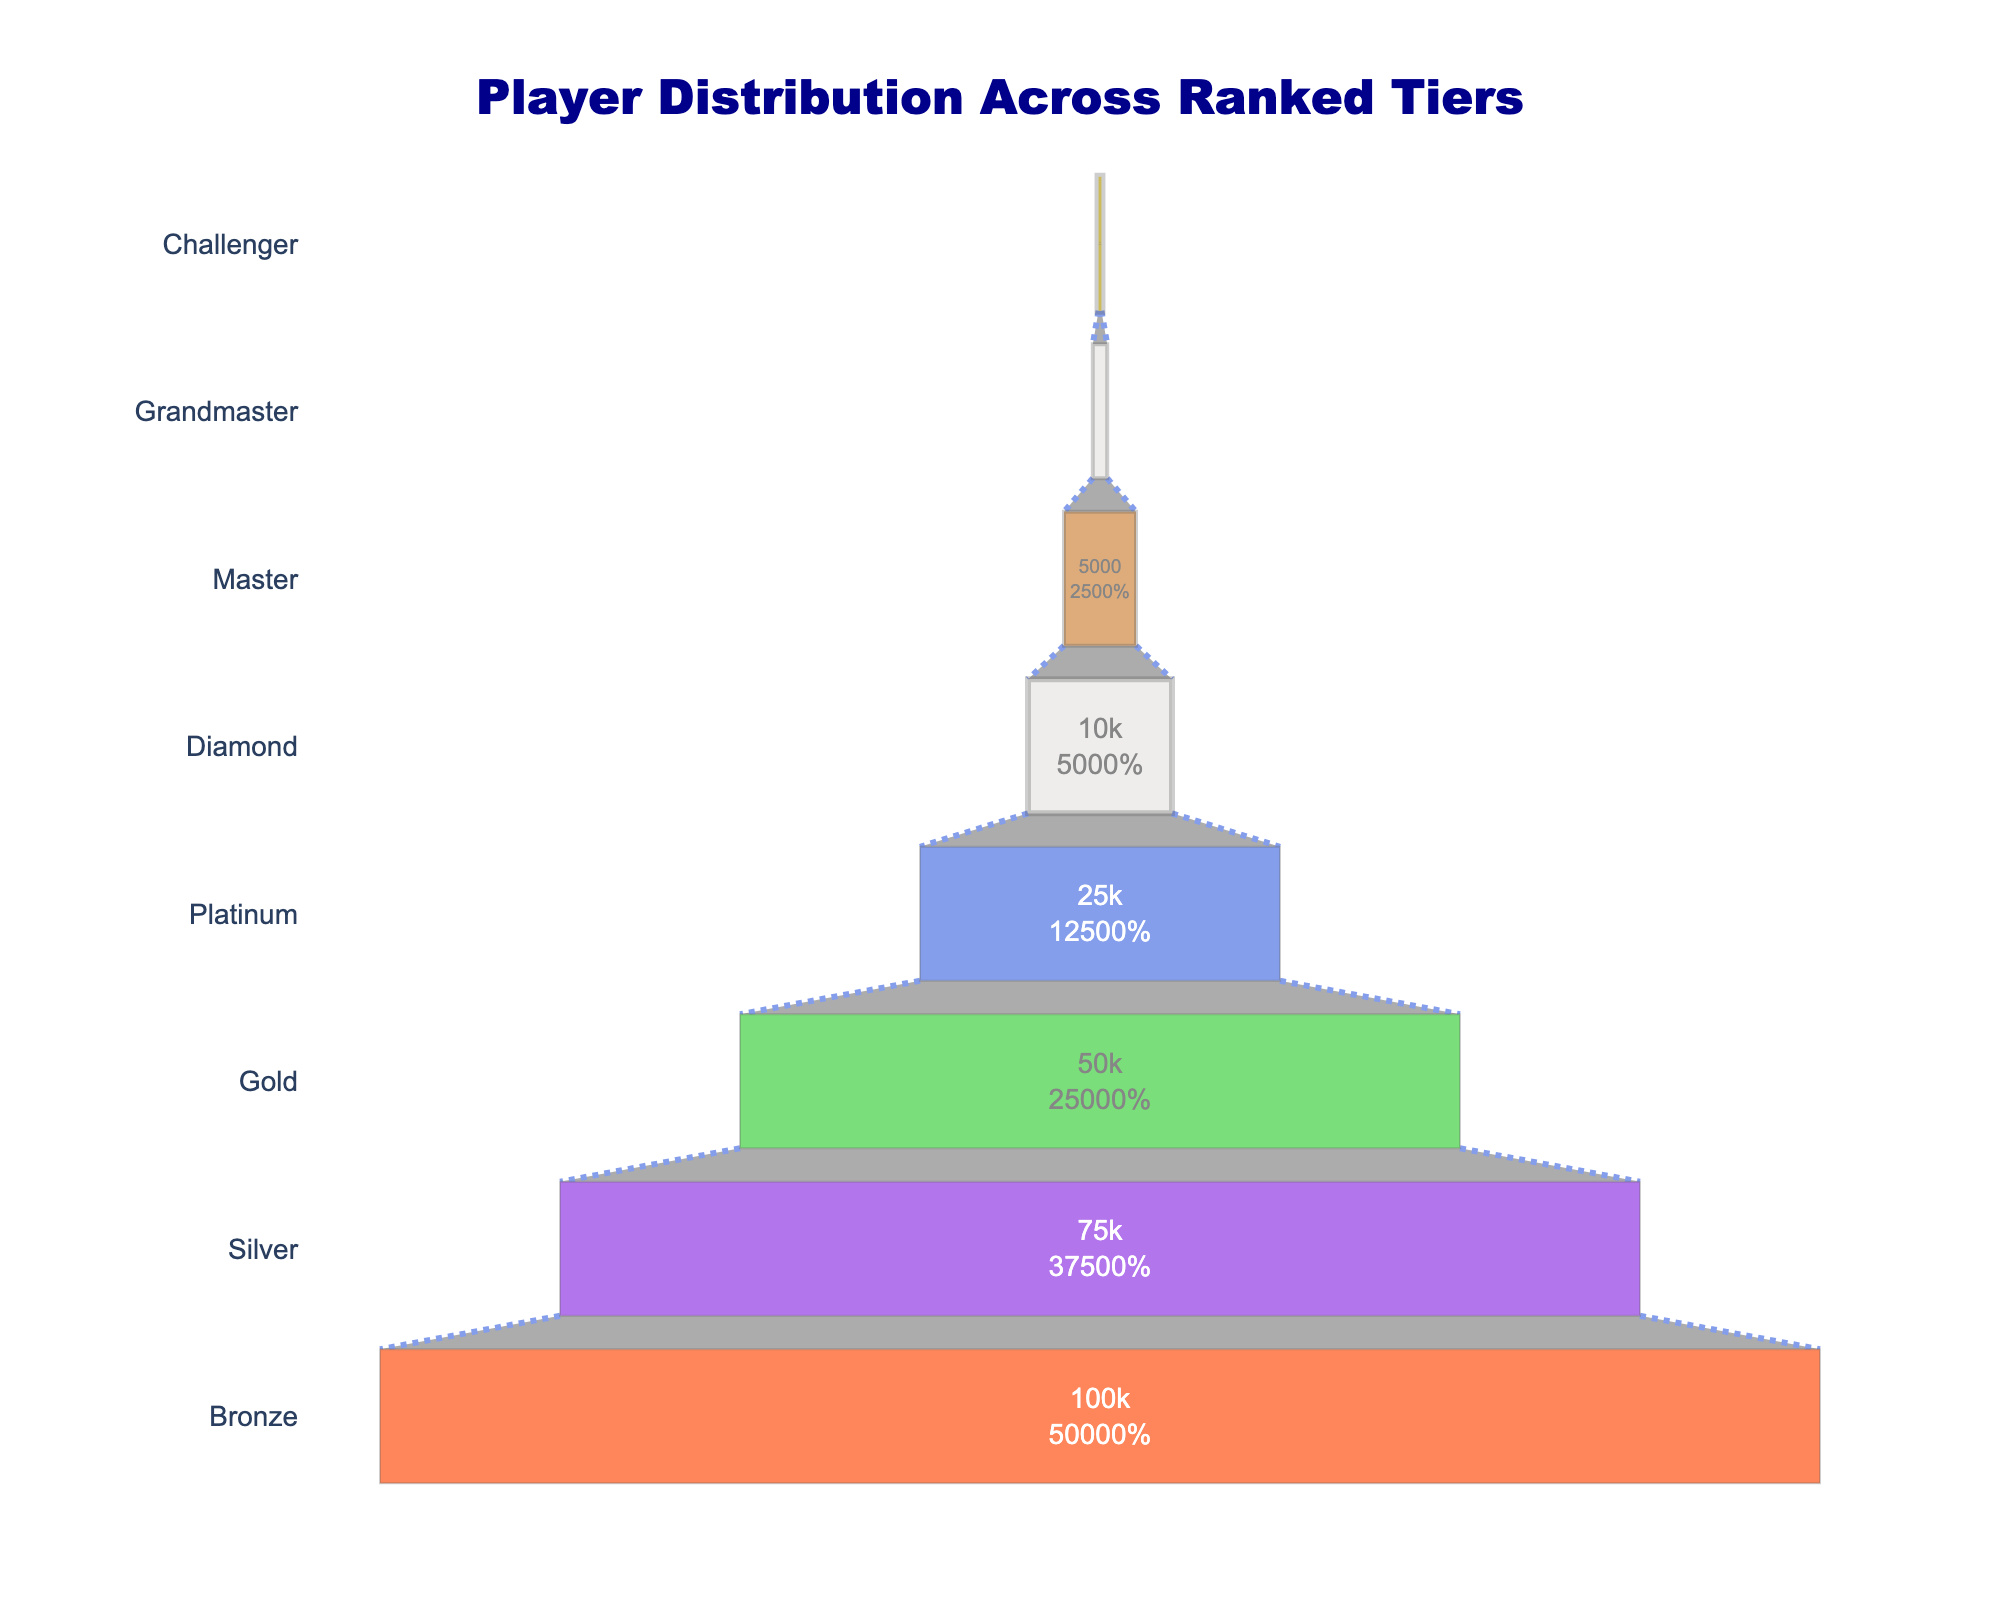How many players are there in the Challenger tier? The funnel chart specifies the number of players at each tier, listing Challenger with 200 players.
Answer: 200 What is the total number of players from Gold to Diamond? Sum the players in Gold (50,000), Platinum (25,000), and Diamond (10,000). 50,000 + 25,000 + 10,000 = 85,000
Answer: 85,000 Which tier has the highest number of players? The chart shows that the Bronze tier has the most players with 100,000.
Answer: Bronze How many players are there in tiers above Diamond? Sum the players in Master (5,000), Grandmaster (1,000), and Challenger (200). 5,000 + 1,000 + 200 = 6,200
Answer: 6,200 What percentage of players are in the Master tier compared to the total player base? Calculate the percentage by dividing the number of players in Master (5,000) by the total number of players (sum of all tiers: 100,000 + 75,000 + 50,000 + 25,000 + 10,000 + 5,000 + 1,000 + 200 = 266,200) and multiply by 100. 5,000 / 266,200 * 100 ≈ 1.88%
Answer: approximately 1.88% How many more players are there in Silver compared to Platinum? Subtract the number of players in Platinum (25,000) from Silver (75,000). 75,000 - 25,000 = 50,000
Answer: 50,000 Which tier saw the largest drop in player count from the previous tier? Compare the differences between consecutive tiers. The largest drop is from Gold (50,000) to Platinum (25,000), a difference of 25,000 players.
Answer: Gold to Platinum If 10% of the Bronze tier players were promoted to Silver, how many Bronze players would remain? Calculate 10% of 100,000 (10,000) and subtract from 100,000. 100,000 - 10,000 = 90,000
Answer: 90,000 Compare the player decline from Gold to Diamond versus from Master to Challenger. Which is greater? Calculate the decline from Gold to Diamond (50,000 - 10,000 = 40,000) and from Master to Challenger (5,000 - 200 = 4,800). The decline from Gold to Diamond is greater.
Answer: Gold to Diamond 